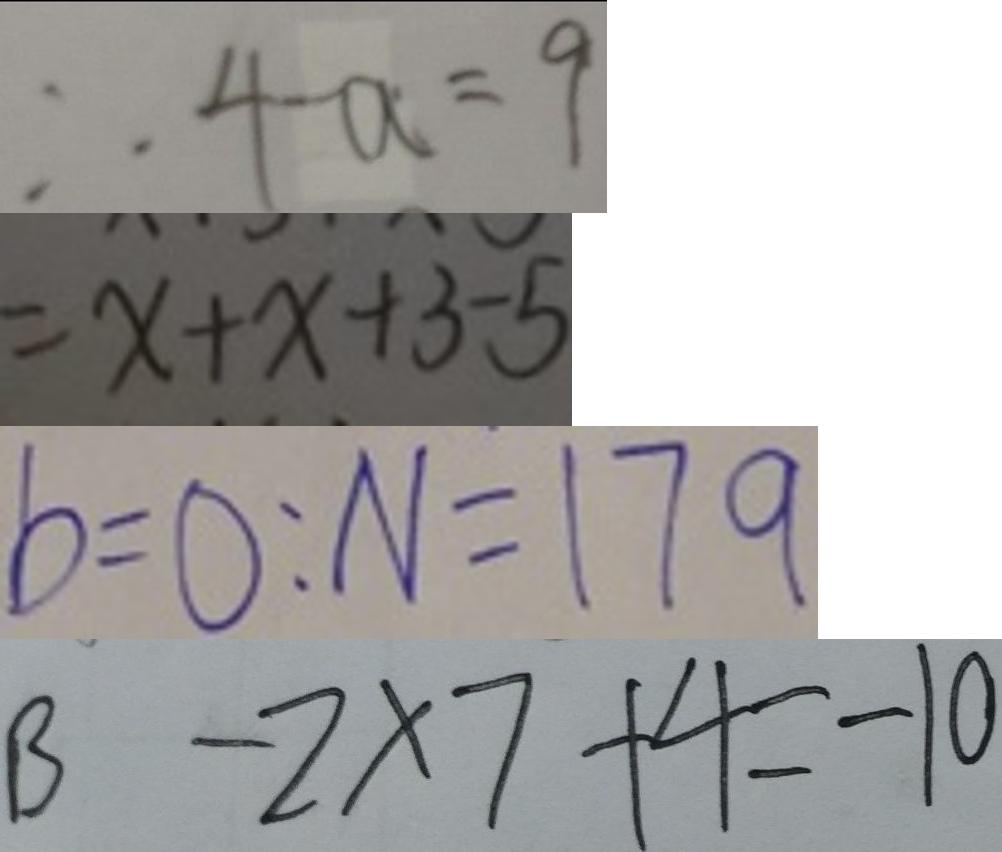<formula> <loc_0><loc_0><loc_500><loc_500>\therefore 4 - a = 9 
 = x + x + 3 - 5 
 b = 0 : N = 1 7 9 
 B - 2 \times 7 + 4 = - 1 0</formula> 